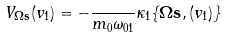<formula> <loc_0><loc_0><loc_500><loc_500>V _ { \mathbf \Omega \mathbf s } ( v _ { 1 } ) = - \frac { } { m _ { 0 } \omega _ { 0 1 } } \kappa _ { 1 } \{ \mathbf \Omega \mathbf s , ( v _ { 1 } ) \}</formula> 